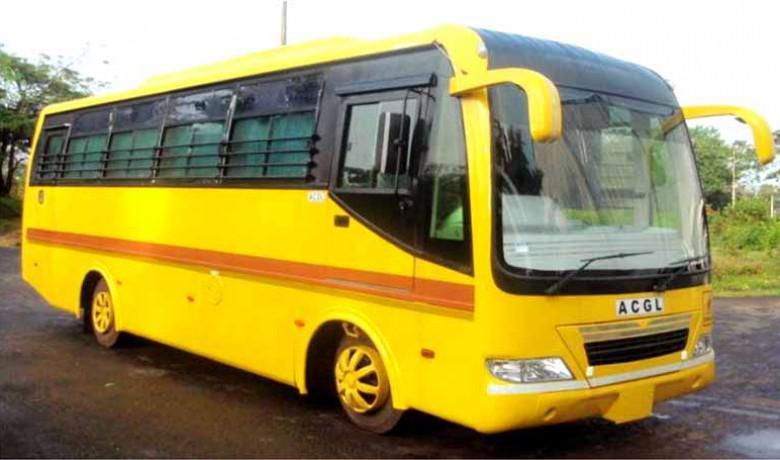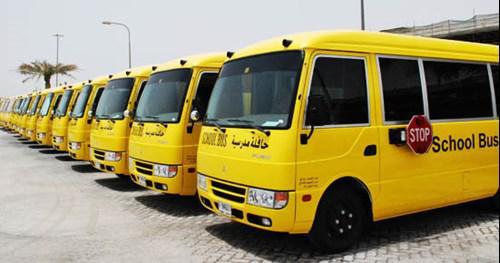The first image is the image on the left, the second image is the image on the right. For the images shown, is this caption "All images show flat-fronted buses parked at a forward angle, and at least one image features a bus with yellow downturned shapes on either side of the windshield." true? Answer yes or no. Yes. The first image is the image on the left, the second image is the image on the right. Considering the images on both sides, is "One of the pictures shows at least six school buses parked next to each other." valid? Answer yes or no. Yes. 